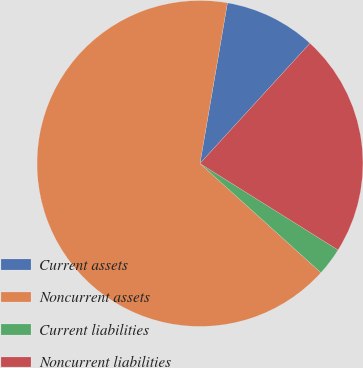Convert chart to OTSL. <chart><loc_0><loc_0><loc_500><loc_500><pie_chart><fcel>Current assets<fcel>Noncurrent assets<fcel>Current liabilities<fcel>Noncurrent liabilities<nl><fcel>9.1%<fcel>66.01%<fcel>2.78%<fcel>22.11%<nl></chart> 